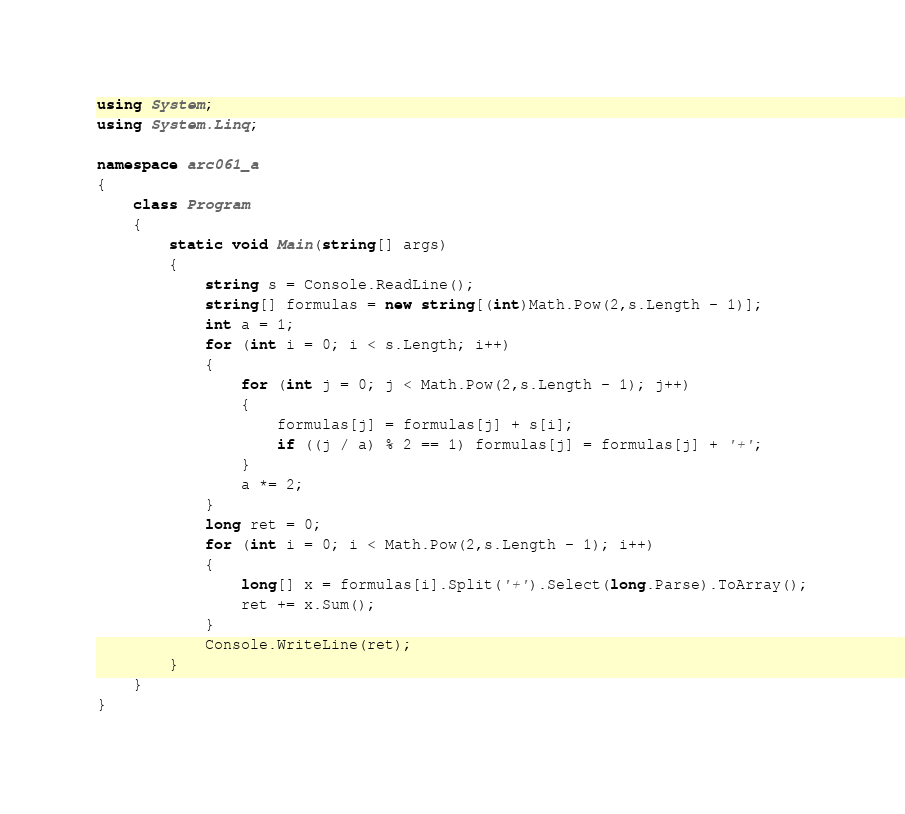<code> <loc_0><loc_0><loc_500><loc_500><_C#_>using System;
using System.Linq;

namespace arc061_a
{
    class Program
    {
        static void Main(string[] args)
        {
            string s = Console.ReadLine();
            string[] formulas = new string[(int)Math.Pow(2,s.Length - 1)];
            int a = 1;
            for (int i = 0; i < s.Length; i++)
            {
                for (int j = 0; j < Math.Pow(2,s.Length - 1); j++)
                {
                    formulas[j] = formulas[j] + s[i];
                    if ((j / a) % 2 == 1) formulas[j] = formulas[j] + '+';
                }
                a *= 2;
            }
            long ret = 0;
            for (int i = 0; i < Math.Pow(2,s.Length - 1); i++)
            {
                long[] x = formulas[i].Split('+').Select(long.Parse).ToArray();
                ret += x.Sum();
            }
            Console.WriteLine(ret);
        }
    }
}</code> 